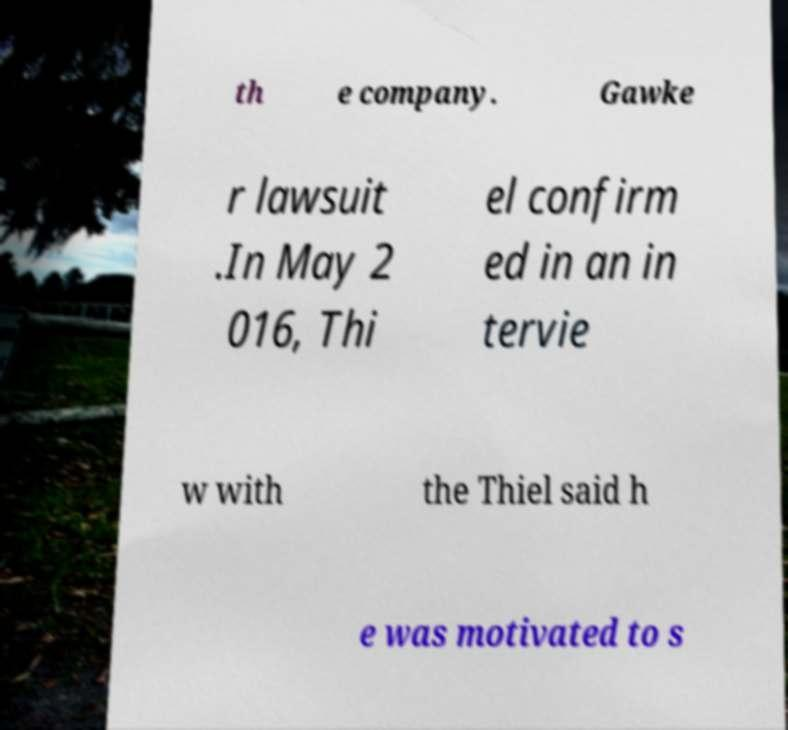I need the written content from this picture converted into text. Can you do that? th e company. Gawke r lawsuit .In May 2 016, Thi el confirm ed in an in tervie w with the Thiel said h e was motivated to s 